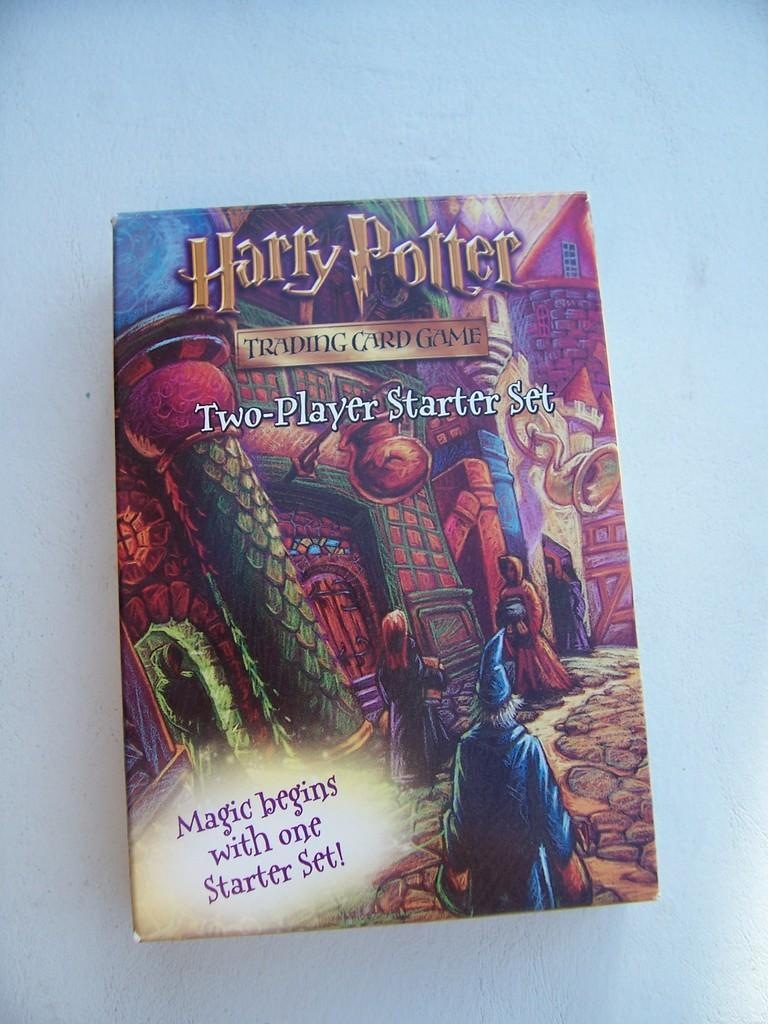Provide a one-sentence caption for the provided image. a cover of a box for a harry potter trading card game. 